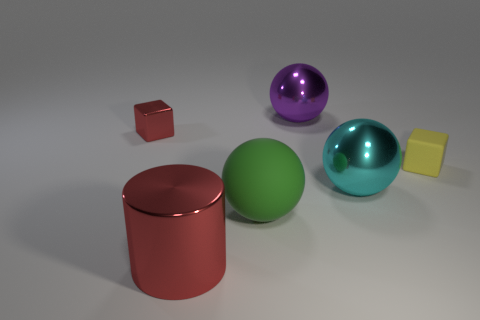Subtract all green rubber spheres. How many spheres are left? 2 Add 2 small brown matte objects. How many objects exist? 8 Subtract 1 cylinders. How many cylinders are left? 0 Subtract all red blocks. How many blocks are left? 1 Add 6 large green matte balls. How many large green matte balls exist? 7 Subtract 0 blue balls. How many objects are left? 6 Subtract all cubes. How many objects are left? 4 Subtract all green blocks. Subtract all yellow cylinders. How many blocks are left? 2 Subtract all red shiny blocks. Subtract all red metallic cylinders. How many objects are left? 4 Add 5 purple metallic balls. How many purple metallic balls are left? 6 